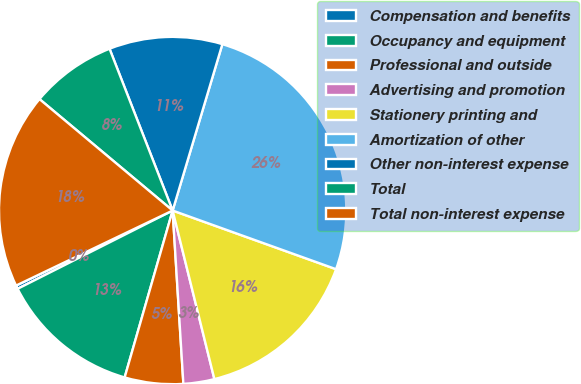Convert chart. <chart><loc_0><loc_0><loc_500><loc_500><pie_chart><fcel>Compensation and benefits<fcel>Occupancy and equipment<fcel>Professional and outside<fcel>Advertising and promotion<fcel>Stationery printing and<fcel>Amortization of other<fcel>Other non-interest expense<fcel>Total<fcel>Total non-interest expense<nl><fcel>0.33%<fcel>13.1%<fcel>5.44%<fcel>2.88%<fcel>15.65%<fcel>25.86%<fcel>10.54%<fcel>7.99%<fcel>18.2%<nl></chart> 